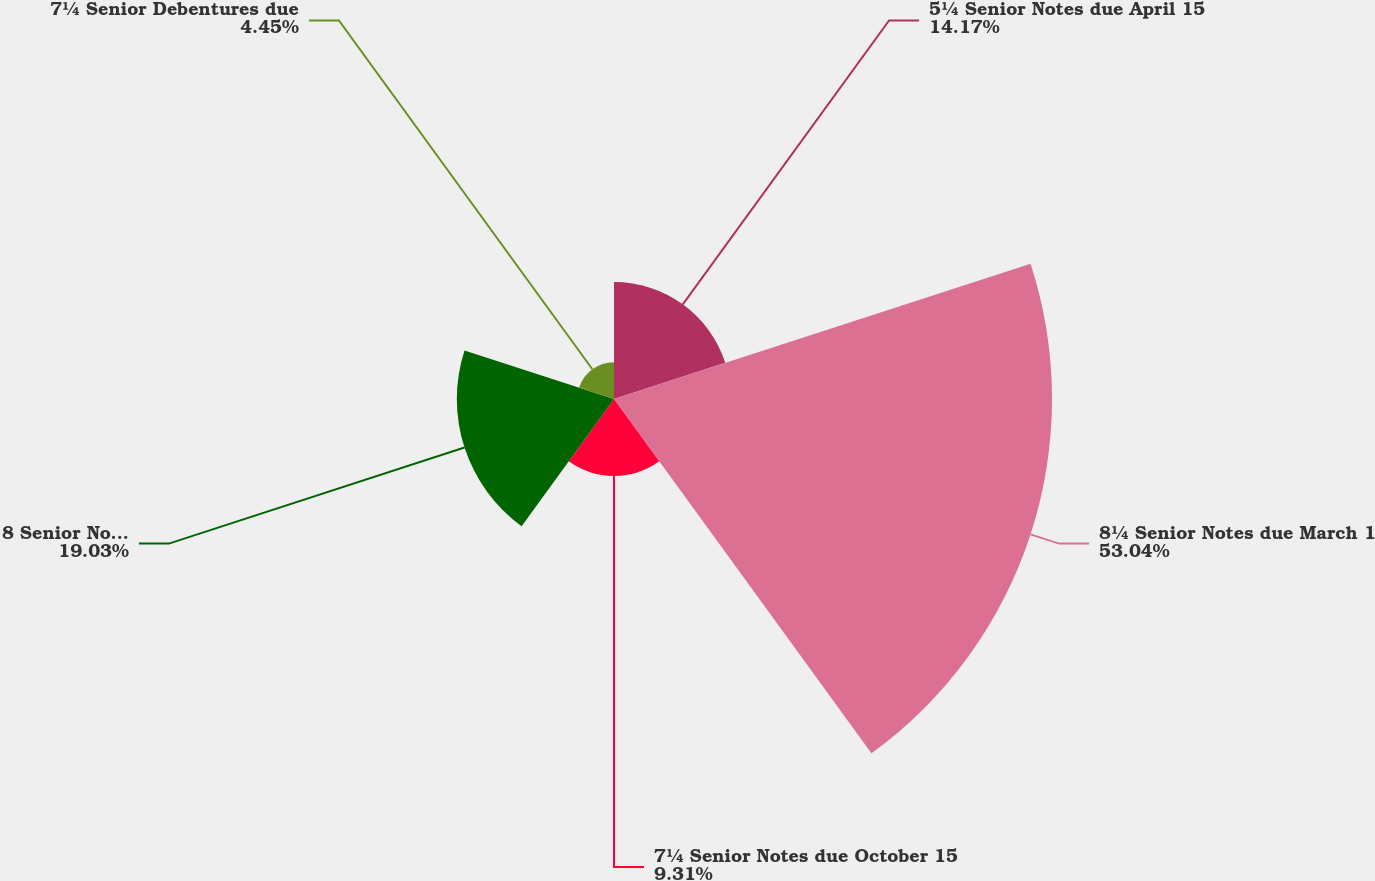Convert chart to OTSL. <chart><loc_0><loc_0><loc_500><loc_500><pie_chart><fcel>5¼ Senior Notes due April 15<fcel>8¼ Senior Notes due March 1<fcel>7¼ Senior Notes due October 15<fcel>8 Senior Notes due April 1<fcel>7¼ Senior Debentures due<nl><fcel>14.17%<fcel>53.03%<fcel>9.31%<fcel>19.03%<fcel>4.45%<nl></chart> 